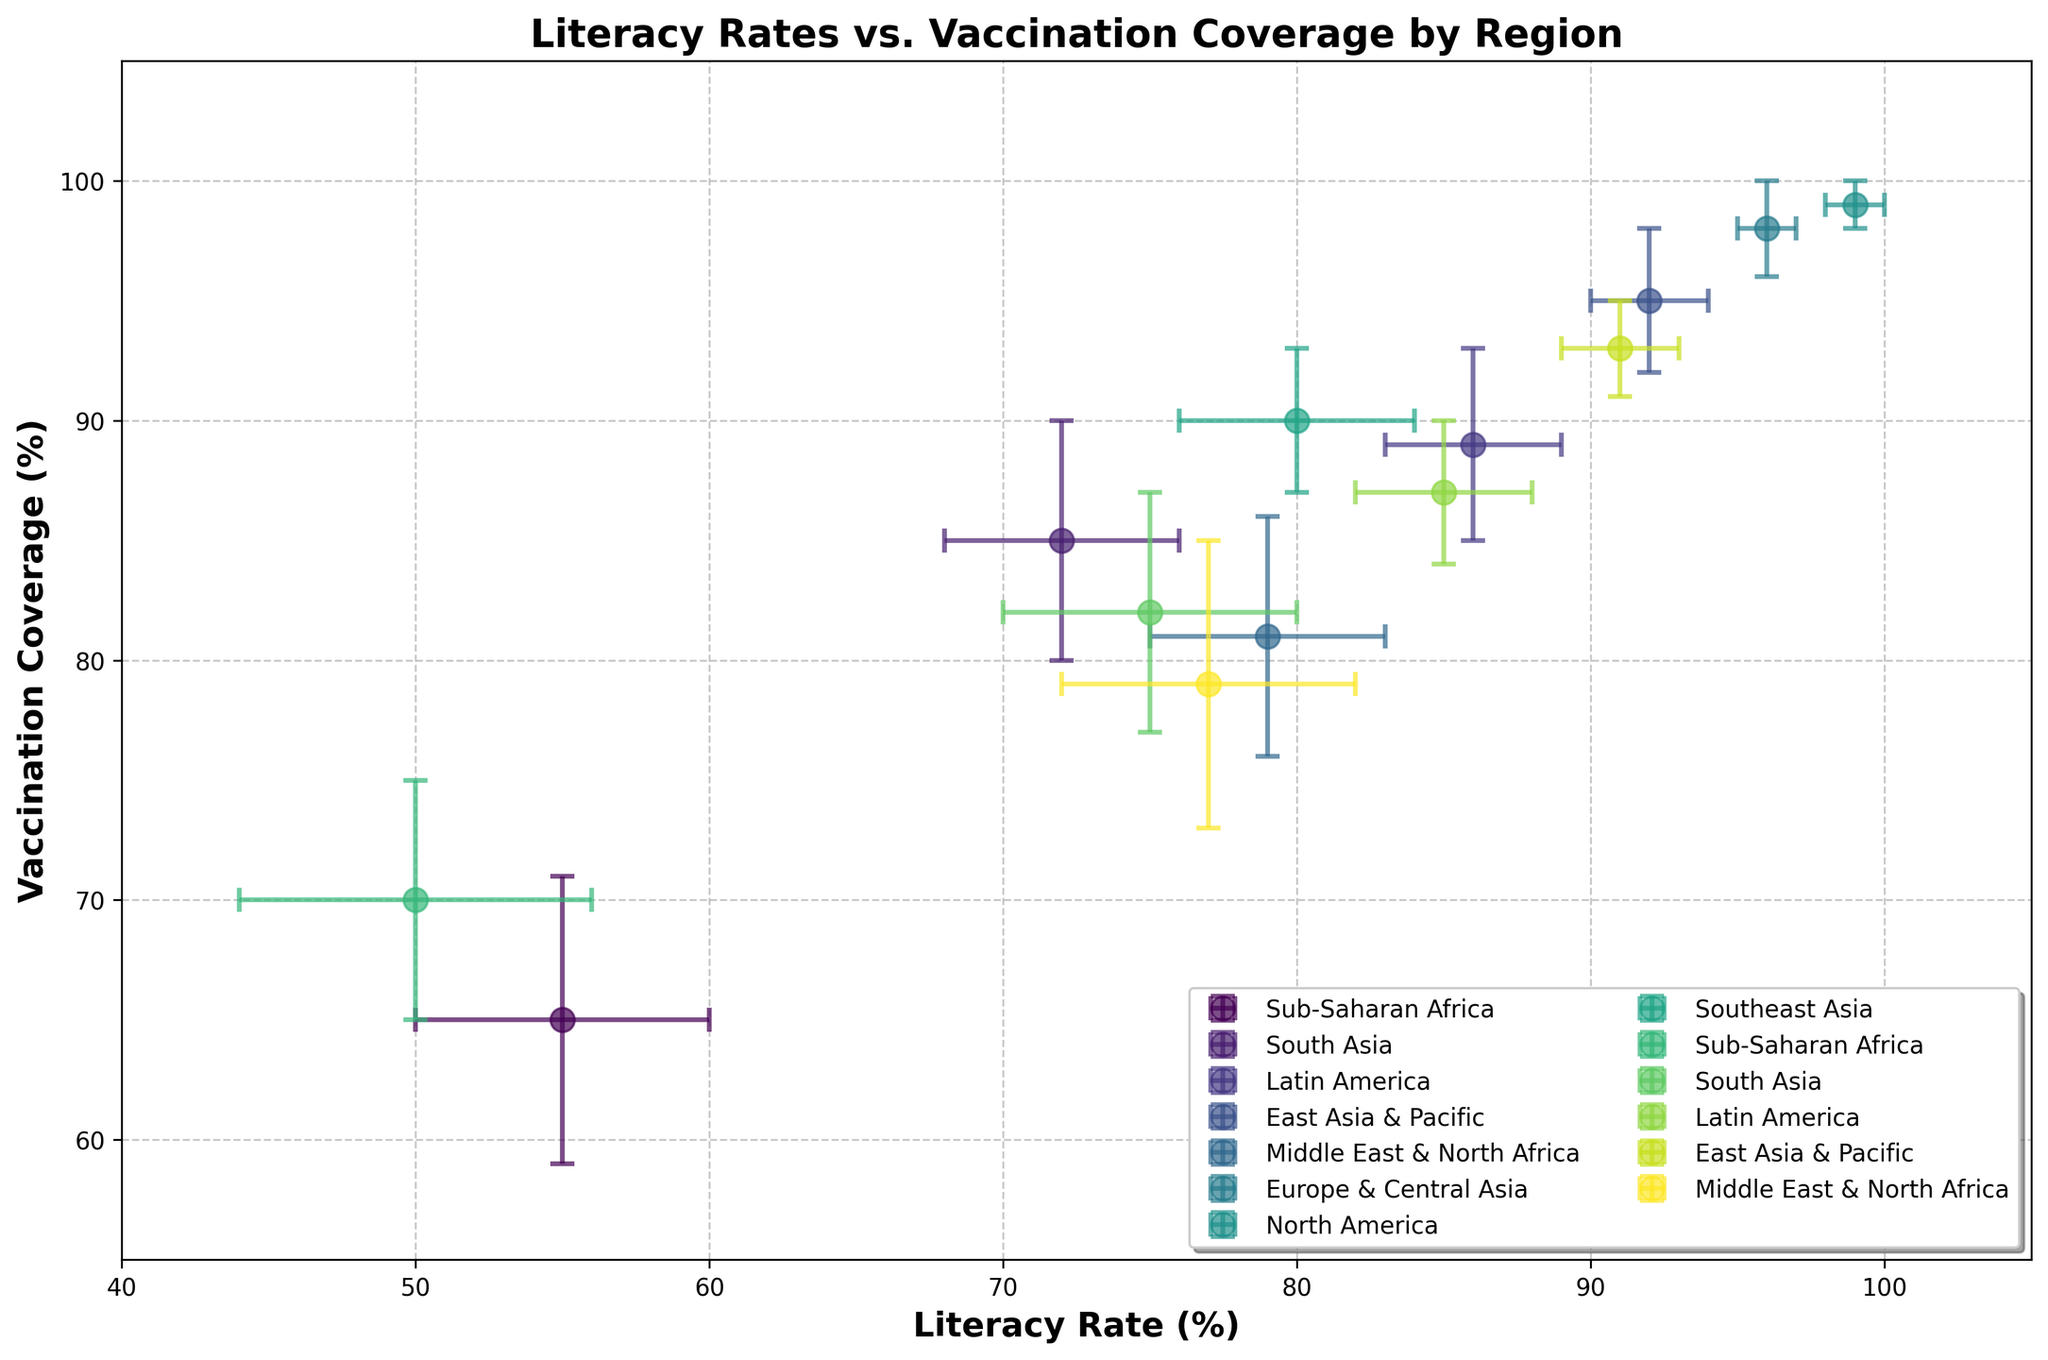Which region has the highest literacy rate? The region with the highest literacy rate is the one placed farthest to the right on the x-axis.
Answer: North America What is the title of the figure? The title is located at the top and clearly describes the relationship depicted in the figure.
Answer: Literacy Rates vs. Vaccination Coverage by Region Which region shows the greatest error in vaccination coverage? The area with the longest error bar along the y-axis indicates the greatest error in vaccination coverage.
Answer: Sub-Saharan Africa Which two regions have the smallest difference in vaccination coverage? By comparing the y-axis positions of the data points, look for two regions that are closest to each other vertically.
Answer: South Asia and Southeast Asia What is the average vaccination coverage error for Europe & Central Asia and North America? The errors are 2% and 1%, respectively. Average them by adding and dividing by 2. (2 + 1) / 2 = 1.5
Answer: 1.5% Which region has the highest disparity between literacy rate and vaccination coverage? Identify regions by calculating the absolute difference between the x and y coordinates, the largest value indicates the highest disparity.
Answer: Sub-Saharan Africa Is Latin America's literacy rate higher than South Asia's literacy rate? Compare the position of Latin America and South Asia on the x-axis to determine which is farther to the right.
Answer: Yes Which regions have literacy rates above 75% and vaccination coverage below 90%? Identify regions where the x-axis value > 75 and y-axis value < 90.
Answer: Middle East & North Africa, Southeast Asia Does a higher literacy rate generally correlate with higher vaccination coverage in the figure? Observe the overall trend from left to right; if both x and y values increase together, this indicates a positive correlation.
Answer: Yes How do the error bars of Middle East & North Africa compare to those of South Asia for literacy rate? Compare the lengths of the horizontal error bars of both regions; longer bars indicate greater error.
Answer: Both have similar literacy rate error bars, around 4-5% 